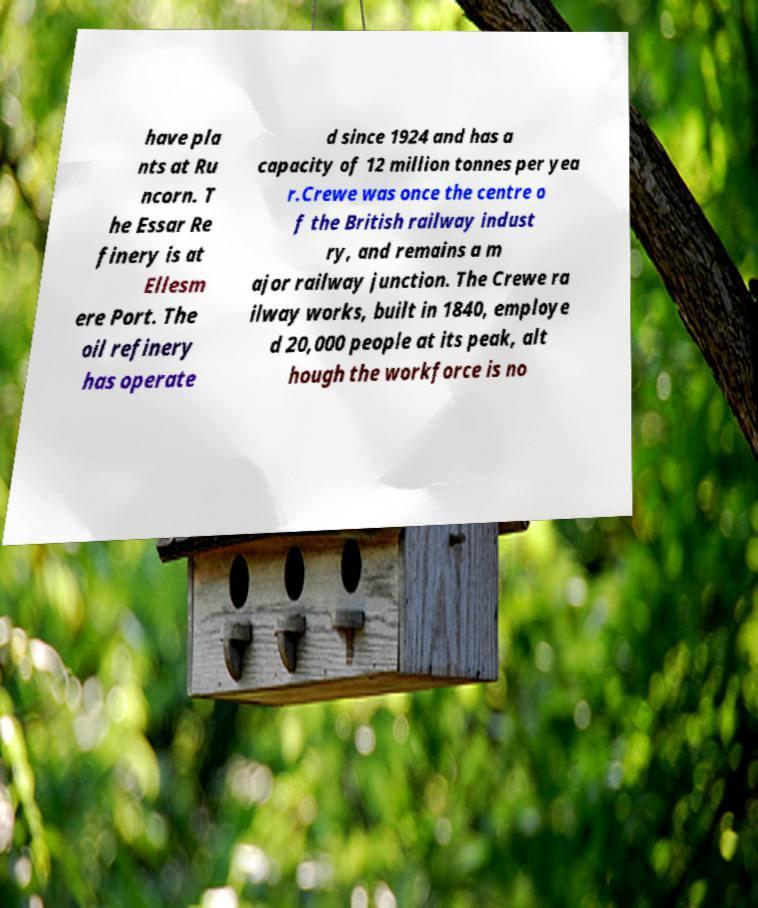Please identify and transcribe the text found in this image. have pla nts at Ru ncorn. T he Essar Re finery is at Ellesm ere Port. The oil refinery has operate d since 1924 and has a capacity of 12 million tonnes per yea r.Crewe was once the centre o f the British railway indust ry, and remains a m ajor railway junction. The Crewe ra ilway works, built in 1840, employe d 20,000 people at its peak, alt hough the workforce is no 